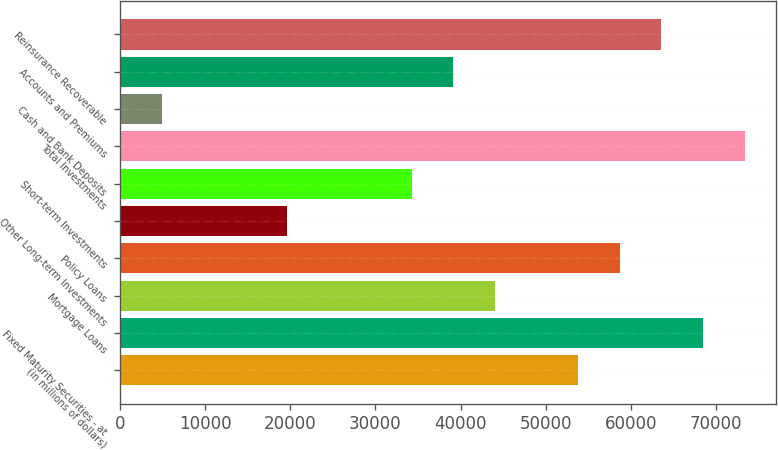<chart> <loc_0><loc_0><loc_500><loc_500><bar_chart><fcel>(in millions of dollars)<fcel>Fixed Maturity Securities - at<fcel>Mortgage Loans<fcel>Policy Loans<fcel>Other Long-term Investments<fcel>Short-term Investments<fcel>Total Investments<fcel>Cash and Bank Deposits<fcel>Accounts and Premiums<fcel>Reinsurance Recoverable<nl><fcel>53801.4<fcel>68460.7<fcel>44028.4<fcel>58687.8<fcel>19596.1<fcel>34255.5<fcel>73347.2<fcel>4936.76<fcel>39142<fcel>63574.3<nl></chart> 